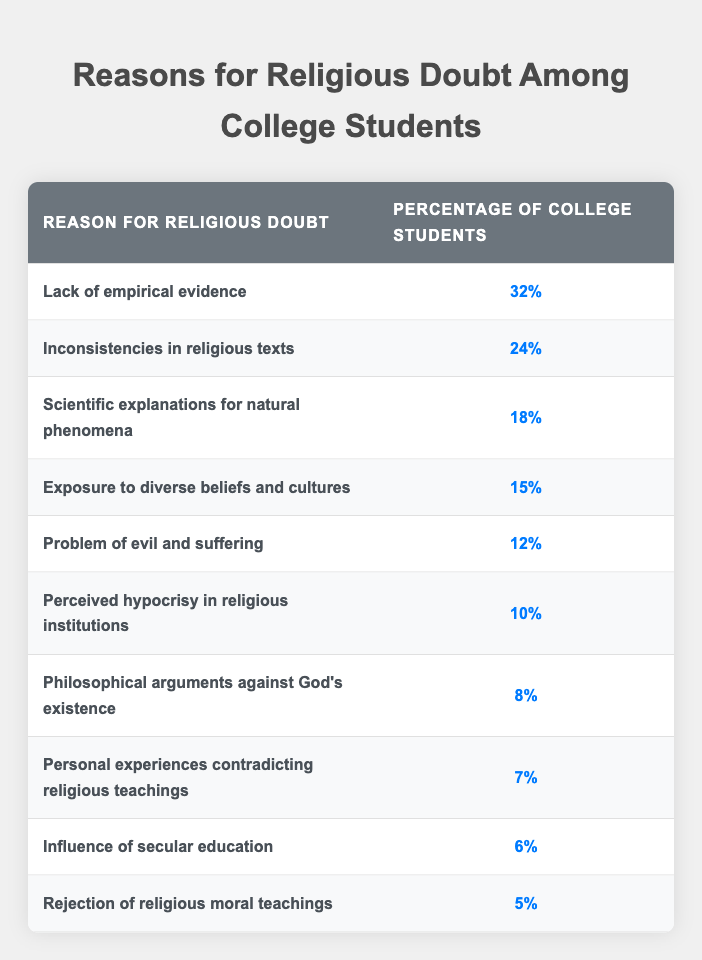What is the most common reason for religious doubt among college students? The table indicates that "Lack of empirical evidence" is noted by 32% of college students as the primary reason for their religious doubt, which is the highest percentage in the list.
Answer: Lack of empirical evidence What percentage of students doubt because of inconsistencies in religious texts? The table shows that 24% of college students doubt due to inconsistencies in religious texts, as listed directly in the second row under "Percentage of College Students."
Answer: 24% What is the combined percentage of students who doubt because of scientific explanations for natural phenomena and exposure to diverse beliefs and cultures? The percentage for scientific explanations for natural phenomena is 18%, and for exposure to diverse beliefs and cultures, it is 15%. Adding these together gives 18% + 15% = 33%.
Answer: 33% Is the percentage of students doubting due to perceived hypocrisy in religious institutions greater than those doubting due to the influence of secular education? The percentage for perceived hypocrisy is 10%, and for the influence of secular education, it is 6%. Since 10% is greater than 6%, the statement is true.
Answer: Yes What percentage of students cite personal experiences contradicting religious teachings and how does it compare to the combined percentage of students doubting due to philosophical arguments against God's existence and rejection of religious moral teachings? The percentage for personal experiences contradicting religious teachings is 7%. For philosophical arguments against God's existence, it is 8%, and for rejection of religious moral teachings, it is 5%. Adding the latter two gives 8% + 5% = 13%. Therefore, 7% is less than 13%.
Answer: 7%; it is less than 13% What is the average percentage of students doubting for reasons that include exposure to diverse beliefs and cultures, the problem of evil and suffering, and perceived hypocrisy in religious institutions? The percentages for these are 15%, 12%, and 10%, respectively. Summing them gives 15% + 12% + 10% = 37%. To find the average, divide by 3 (the number of reasons), which yields 37% / 3 = 12.33%.
Answer: 12.33% 